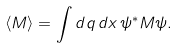Convert formula to latex. <formula><loc_0><loc_0><loc_500><loc_500>\langle M \rangle = \int d q \, d x \, \psi ^ { * } M \psi .</formula> 